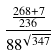<formula> <loc_0><loc_0><loc_500><loc_500>\frac { \frac { 2 6 8 + 7 } { 2 3 6 } } { 8 8 ^ { \sqrt { 3 4 7 } } }</formula> 